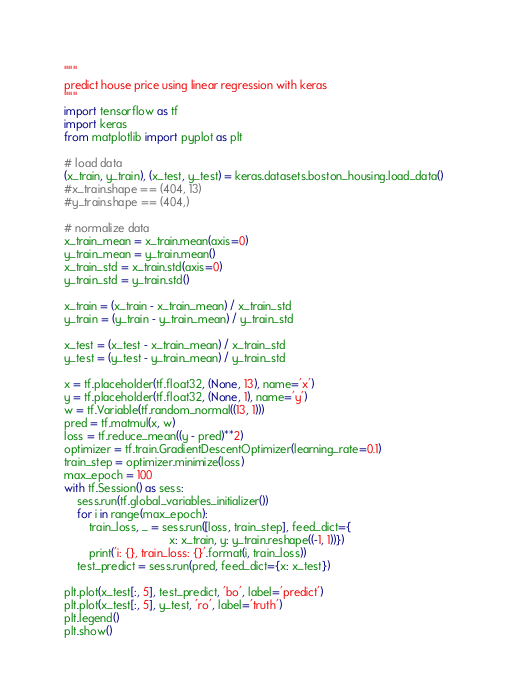Convert code to text. <code><loc_0><loc_0><loc_500><loc_500><_Python_>"""
predict house price using linear regression with keras
"""
import tensorflow as tf
import keras
from matplotlib import pyplot as plt

# load data
(x_train, y_train), (x_test, y_test) = keras.datasets.boston_housing.load_data()
#x_train.shape == (404, 13)
#y_train.shape == (404,)

# normalize data
x_train_mean = x_train.mean(axis=0)
y_train_mean = y_train.mean()
x_train_std = x_train.std(axis=0)
y_train_std = y_train.std()

x_train = (x_train - x_train_mean) / x_train_std
y_train = (y_train - y_train_mean) / y_train_std

x_test = (x_test - x_train_mean) / x_train_std
y_test = (y_test - y_train_mean) / y_train_std

x = tf.placeholder(tf.float32, (None, 13), name='x')
y = tf.placeholder(tf.float32, (None, 1), name='y')
w = tf.Variable(tf.random_normal((13, 1)))
pred = tf.matmul(x, w)
loss = tf.reduce_mean((y - pred)**2)
optimizer = tf.train.GradientDescentOptimizer(learning_rate=0.1)
train_step = optimizer.minimize(loss)
max_epoch = 100
with tf.Session() as sess:
    sess.run(tf.global_variables_initializer())
    for i in range(max_epoch):
        train_loss, _ = sess.run([loss, train_step], feed_dict={
                                 x: x_train, y: y_train.reshape((-1, 1))})
        print('i: {}, train_loss: {}'.format(i, train_loss))
    test_predict = sess.run(pred, feed_dict={x: x_test})

plt.plot(x_test[:, 5], test_predict, 'bo', label='predict')
plt.plot(x_test[:, 5], y_test, 'ro', label='truth')
plt.legend()
plt.show()
</code> 